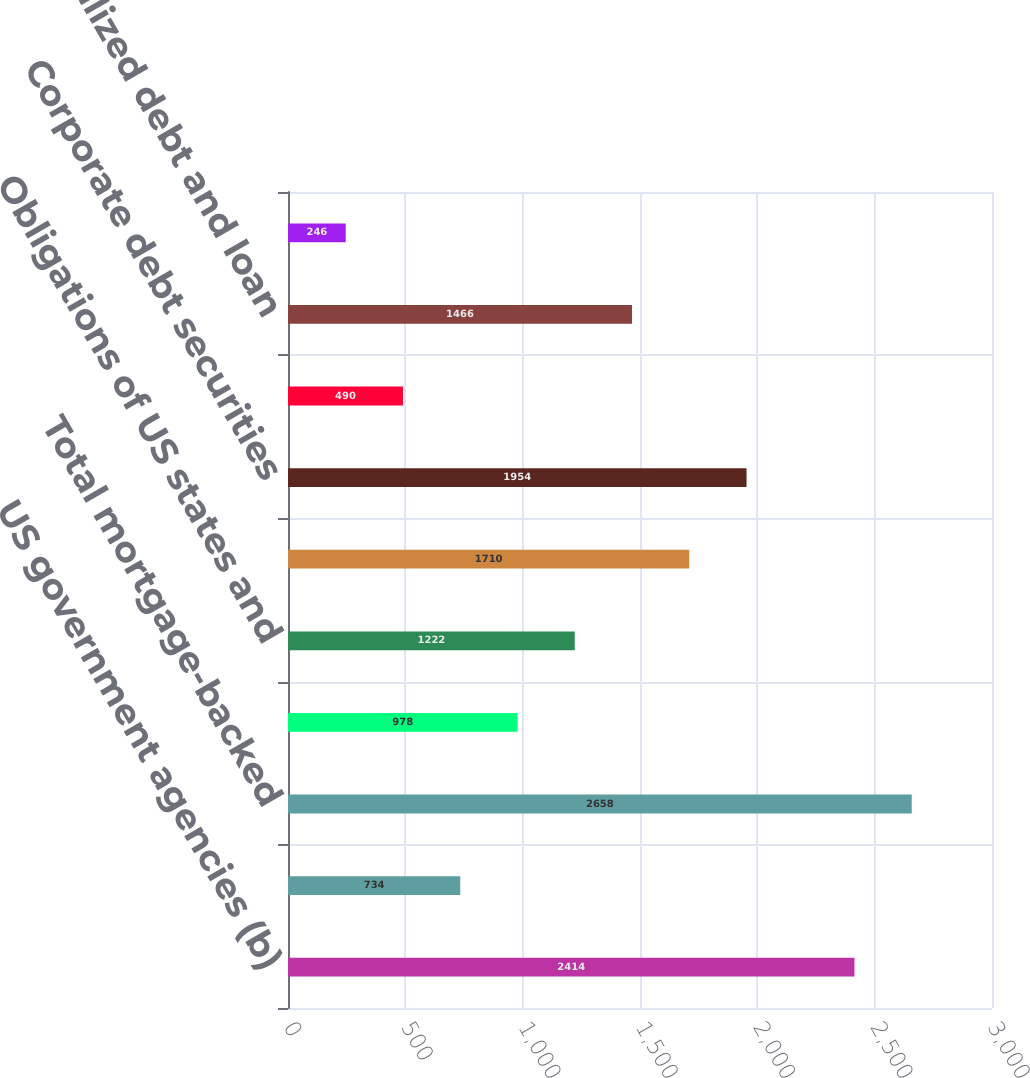Convert chart to OTSL. <chart><loc_0><loc_0><loc_500><loc_500><bar_chart><fcel>US government agencies (b)<fcel>Non-US<fcel>Total mortgage-backed<fcel>US Treasury and government<fcel>Obligations of US states and<fcel>Non-US government debt<fcel>Corporate debt securities<fcel>Credit card receivables<fcel>Collateralized debt and loan<fcel>Other<nl><fcel>2414<fcel>734<fcel>2658<fcel>978<fcel>1222<fcel>1710<fcel>1954<fcel>490<fcel>1466<fcel>246<nl></chart> 